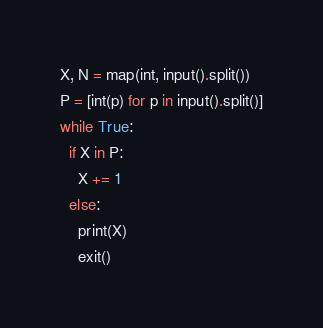<code> <loc_0><loc_0><loc_500><loc_500><_Python_>X, N = map(int, input().split())
P = [int(p) for p in input().split()]
while True:
  if X in P:
    X += 1
  else:
    print(X)
    exit()</code> 